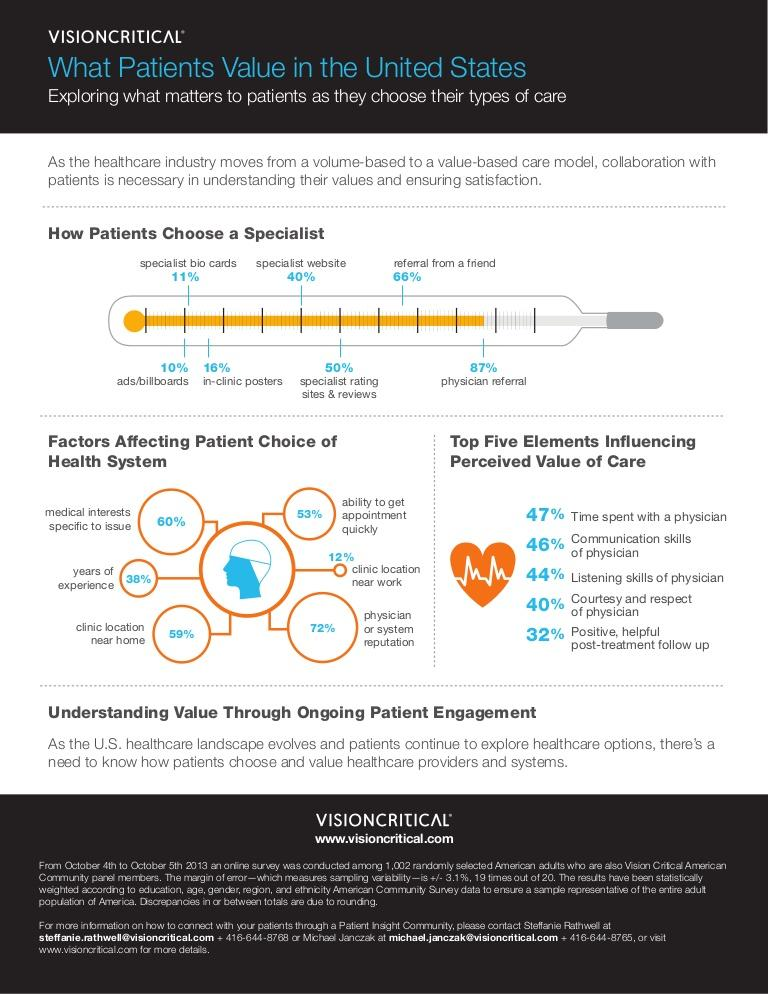Draw attention to some important aspects in this diagram. Reputation of physicians and healthcare systems play a significant role in influencing patients' decisions regarding their preferred healthcare system in the United States. For many patients in the United States, clinic location near their place of work is considered the least important factor when it comes to choosing a healthcare system. In the United States, a significant percentage of patients choose a specialist based on the in-clinic posters, with 16% being the reported figure. According to a survey conducted in the United States, the least preferred method of selecting a specialist among patients is advertisements and billboards. According to data in the United States, approximately 40% of patients choose a specialist based on the specialist's website. 